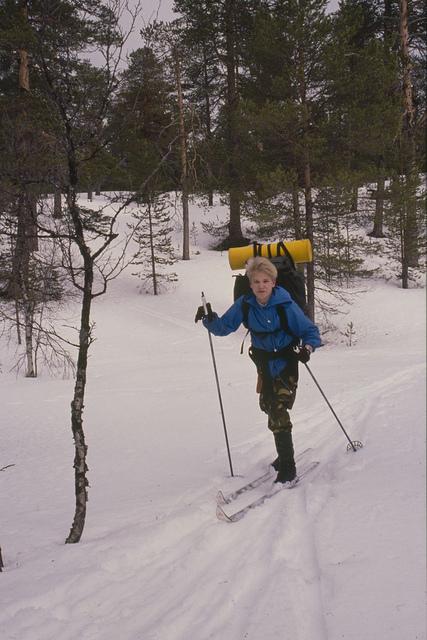What is on his back?
Write a very short answer. Backpack. What season is it?
Concise answer only. Winter. What type of skiing is this person engaging in?
Quick response, please. Cross country. Is the skier easily carrying his gear, or is he struggling?
Quick response, please. Easily. 